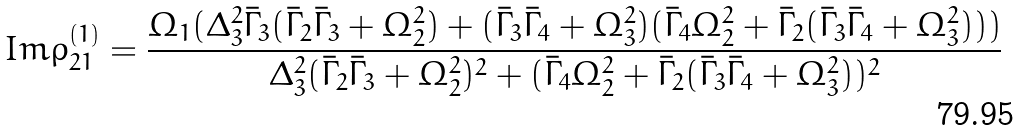Convert formula to latex. <formula><loc_0><loc_0><loc_500><loc_500>I m \rho _ { 2 1 } ^ { ( 1 ) } = \frac { \Omega _ { 1 } ( \Delta _ { 3 } ^ { 2 } \bar { \Gamma } _ { 3 } ( \bar { \Gamma } _ { 2 } \bar { \Gamma } _ { 3 } + \Omega _ { 2 } ^ { 2 } ) + ( \bar { \Gamma } _ { 3 } \bar { \Gamma } _ { 4 } + \Omega _ { 3 } ^ { 2 } ) ( \bar { \Gamma } _ { 4 } \Omega _ { 2 } ^ { 2 } + \bar { \Gamma } _ { 2 } ( \bar { \Gamma } _ { 3 } \bar { \Gamma } _ { 4 } + \Omega _ { 3 } ^ { 2 } ) ) ) } { \Delta _ { 3 } ^ { 2 } ( \bar { \Gamma } _ { 2 } \bar { \Gamma } _ { 3 } + \Omega _ { 2 } ^ { 2 } ) ^ { 2 } + ( \bar { \Gamma } _ { 4 } \Omega _ { 2 } ^ { 2 } + \bar { \Gamma } _ { 2 } ( \bar { \Gamma } _ { 3 } \bar { \Gamma } _ { 4 } + \Omega _ { 3 } ^ { 2 } ) ) ^ { 2 } }</formula> 